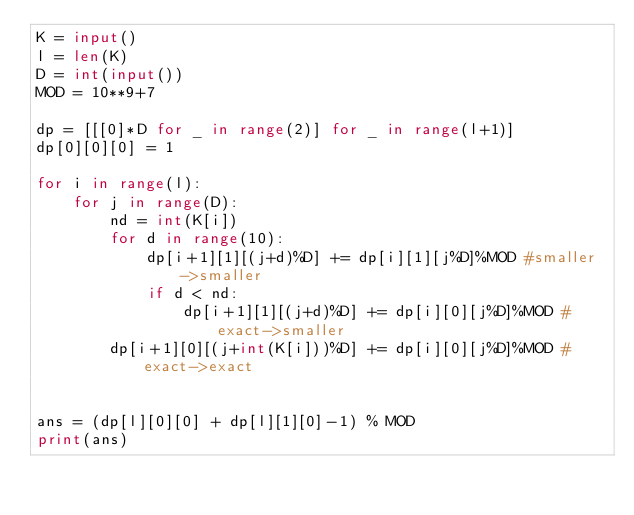Convert code to text. <code><loc_0><loc_0><loc_500><loc_500><_Python_>K = input()
l = len(K)
D = int(input())
MOD = 10**9+7

dp = [[[0]*D for _ in range(2)] for _ in range(l+1)]
dp[0][0][0] = 1

for i in range(l):
    for j in range(D):
        nd = int(K[i])
        for d in range(10):
            dp[i+1][1][(j+d)%D] += dp[i][1][j%D]%MOD #smaller->smaller
            if d < nd:
                dp[i+1][1][(j+d)%D] += dp[i][0][j%D]%MOD #exact->smaller
        dp[i+1][0][(j+int(K[i]))%D] += dp[i][0][j%D]%MOD #exact->exact


ans = (dp[l][0][0] + dp[l][1][0]-1) % MOD
print(ans)</code> 